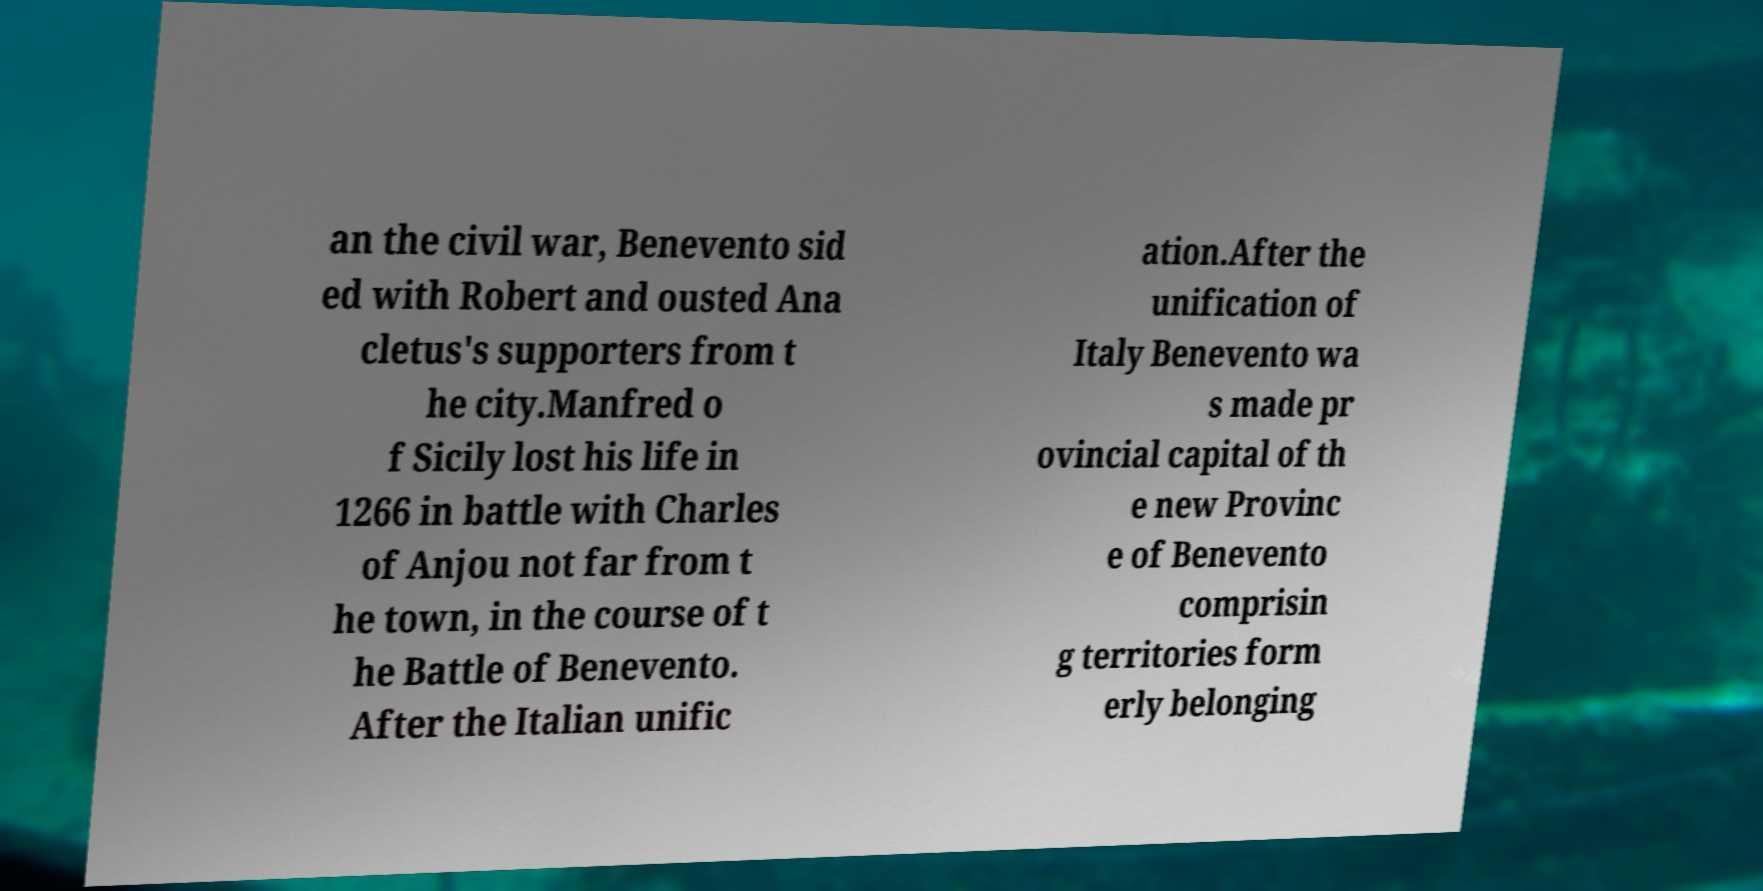There's text embedded in this image that I need extracted. Can you transcribe it verbatim? an the civil war, Benevento sid ed with Robert and ousted Ana cletus's supporters from t he city.Manfred o f Sicily lost his life in 1266 in battle with Charles of Anjou not far from t he town, in the course of t he Battle of Benevento. After the Italian unific ation.After the unification of Italy Benevento wa s made pr ovincial capital of th e new Provinc e of Benevento comprisin g territories form erly belonging 